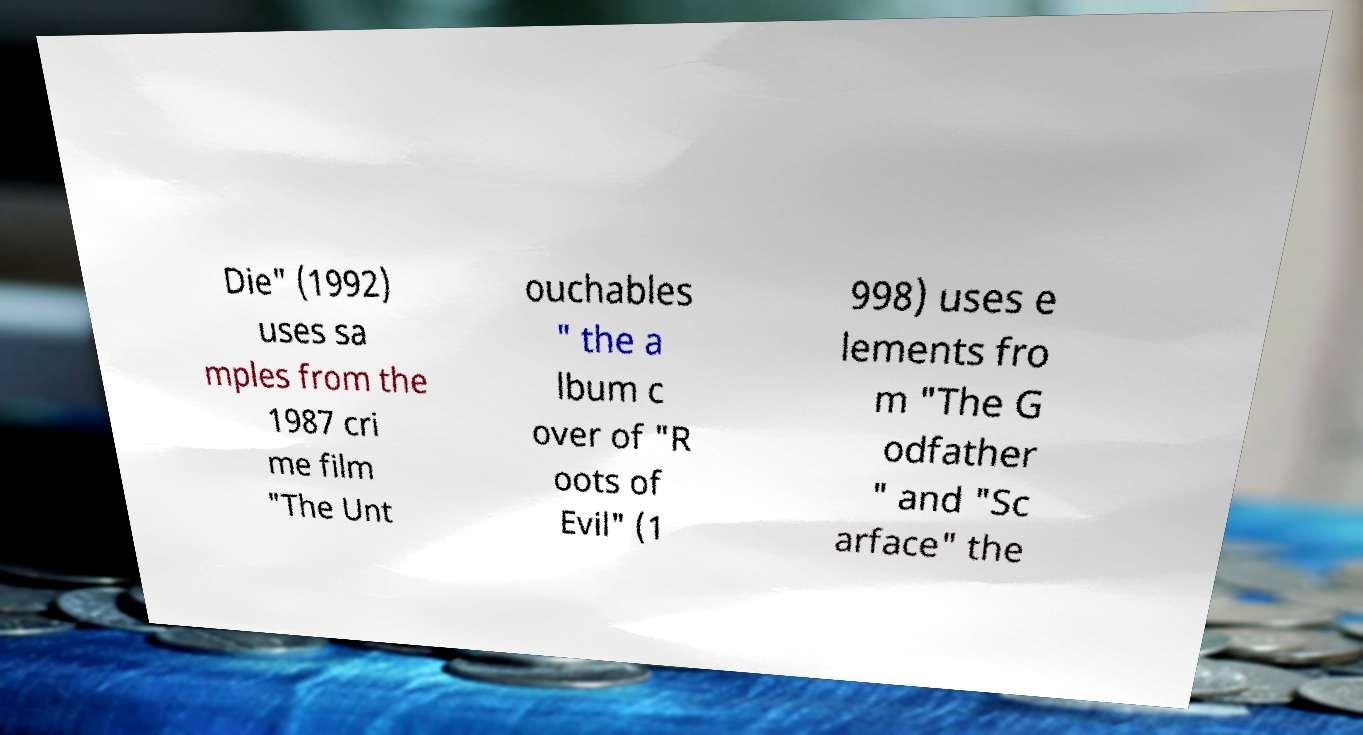Could you extract and type out the text from this image? Die" (1992) uses sa mples from the 1987 cri me film "The Unt ouchables " the a lbum c over of "R oots of Evil" (1 998) uses e lements fro m "The G odfather " and "Sc arface" the 